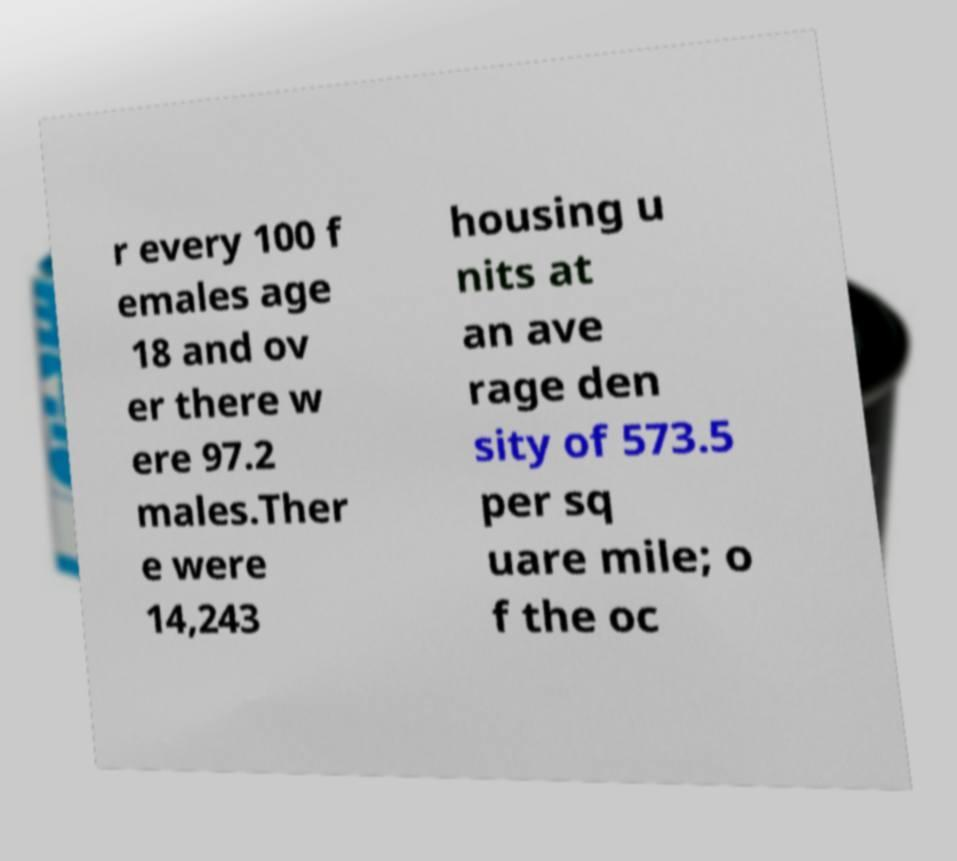What messages or text are displayed in this image? I need them in a readable, typed format. r every 100 f emales age 18 and ov er there w ere 97.2 males.Ther e were 14,243 housing u nits at an ave rage den sity of 573.5 per sq uare mile; o f the oc 